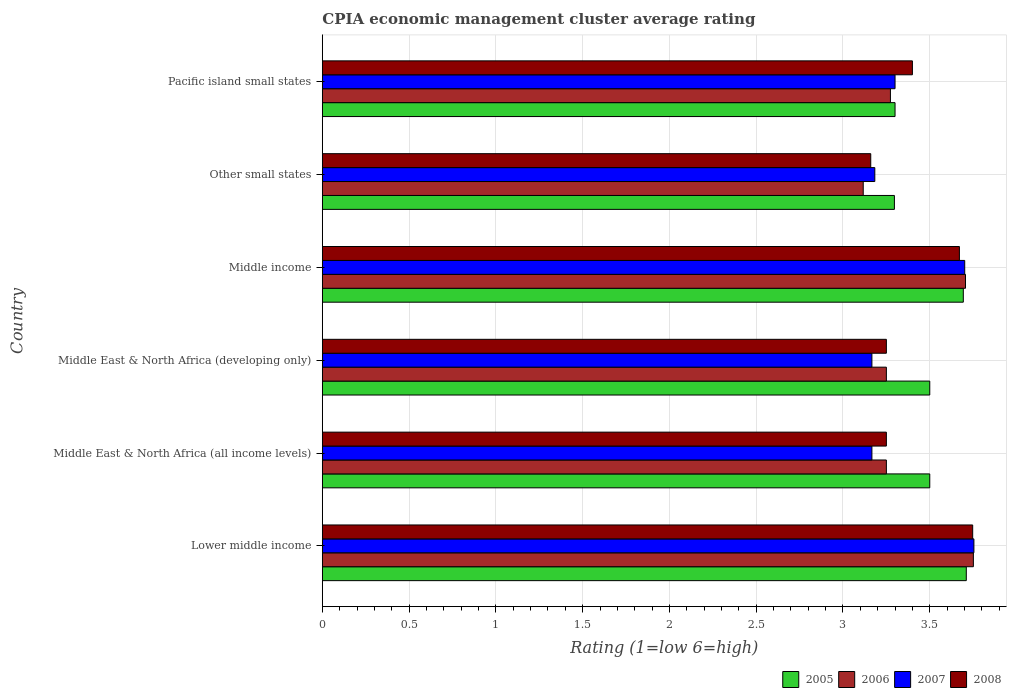Are the number of bars per tick equal to the number of legend labels?
Make the answer very short. Yes. How many bars are there on the 2nd tick from the top?
Your answer should be compact. 4. How many bars are there on the 1st tick from the bottom?
Your answer should be compact. 4. What is the label of the 6th group of bars from the top?
Keep it short and to the point. Lower middle income. In how many cases, is the number of bars for a given country not equal to the number of legend labels?
Make the answer very short. 0. What is the CPIA rating in 2007 in Middle income?
Keep it short and to the point. 3.7. Across all countries, what is the maximum CPIA rating in 2005?
Offer a terse response. 3.71. Across all countries, what is the minimum CPIA rating in 2008?
Provide a succinct answer. 3.16. In which country was the CPIA rating in 2006 maximum?
Offer a terse response. Lower middle income. In which country was the CPIA rating in 2006 minimum?
Ensure brevity in your answer.  Other small states. What is the total CPIA rating in 2006 in the graph?
Provide a short and direct response. 20.35. What is the difference between the CPIA rating in 2007 in Lower middle income and that in Pacific island small states?
Keep it short and to the point. 0.45. What is the difference between the CPIA rating in 2007 in Pacific island small states and the CPIA rating in 2006 in Middle income?
Ensure brevity in your answer.  -0.41. What is the average CPIA rating in 2008 per country?
Offer a terse response. 3.41. What is the difference between the CPIA rating in 2006 and CPIA rating in 2005 in Lower middle income?
Ensure brevity in your answer.  0.04. In how many countries, is the CPIA rating in 2007 greater than 1.2 ?
Provide a succinct answer. 6. What is the ratio of the CPIA rating in 2007 in Middle East & North Africa (all income levels) to that in Other small states?
Your answer should be very brief. 0.99. What is the difference between the highest and the second highest CPIA rating in 2006?
Offer a very short reply. 0.05. What is the difference between the highest and the lowest CPIA rating in 2008?
Offer a terse response. 0.59. In how many countries, is the CPIA rating in 2007 greater than the average CPIA rating in 2007 taken over all countries?
Keep it short and to the point. 2. How many bars are there?
Ensure brevity in your answer.  24. Are all the bars in the graph horizontal?
Keep it short and to the point. Yes. How many countries are there in the graph?
Make the answer very short. 6. Where does the legend appear in the graph?
Keep it short and to the point. Bottom right. How many legend labels are there?
Offer a very short reply. 4. What is the title of the graph?
Provide a short and direct response. CPIA economic management cluster average rating. What is the label or title of the X-axis?
Provide a short and direct response. Rating (1=low 6=high). What is the label or title of the Y-axis?
Offer a very short reply. Country. What is the Rating (1=low 6=high) of 2005 in Lower middle income?
Keep it short and to the point. 3.71. What is the Rating (1=low 6=high) of 2006 in Lower middle income?
Keep it short and to the point. 3.75. What is the Rating (1=low 6=high) of 2007 in Lower middle income?
Your answer should be compact. 3.75. What is the Rating (1=low 6=high) of 2008 in Lower middle income?
Offer a very short reply. 3.75. What is the Rating (1=low 6=high) of 2005 in Middle East & North Africa (all income levels)?
Give a very brief answer. 3.5. What is the Rating (1=low 6=high) of 2006 in Middle East & North Africa (all income levels)?
Offer a terse response. 3.25. What is the Rating (1=low 6=high) in 2007 in Middle East & North Africa (all income levels)?
Make the answer very short. 3.17. What is the Rating (1=low 6=high) in 2008 in Middle East & North Africa (all income levels)?
Offer a very short reply. 3.25. What is the Rating (1=low 6=high) of 2005 in Middle East & North Africa (developing only)?
Give a very brief answer. 3.5. What is the Rating (1=low 6=high) of 2007 in Middle East & North Africa (developing only)?
Your response must be concise. 3.17. What is the Rating (1=low 6=high) of 2008 in Middle East & North Africa (developing only)?
Make the answer very short. 3.25. What is the Rating (1=low 6=high) of 2005 in Middle income?
Your answer should be compact. 3.69. What is the Rating (1=low 6=high) of 2006 in Middle income?
Your answer should be compact. 3.71. What is the Rating (1=low 6=high) in 2007 in Middle income?
Your answer should be compact. 3.7. What is the Rating (1=low 6=high) of 2008 in Middle income?
Provide a succinct answer. 3.67. What is the Rating (1=low 6=high) in 2005 in Other small states?
Ensure brevity in your answer.  3.3. What is the Rating (1=low 6=high) of 2006 in Other small states?
Your answer should be compact. 3.12. What is the Rating (1=low 6=high) of 2007 in Other small states?
Keep it short and to the point. 3.18. What is the Rating (1=low 6=high) of 2008 in Other small states?
Give a very brief answer. 3.16. What is the Rating (1=low 6=high) of 2006 in Pacific island small states?
Offer a terse response. 3.27. What is the Rating (1=low 6=high) of 2007 in Pacific island small states?
Ensure brevity in your answer.  3.3. Across all countries, what is the maximum Rating (1=low 6=high) of 2005?
Keep it short and to the point. 3.71. Across all countries, what is the maximum Rating (1=low 6=high) of 2006?
Offer a very short reply. 3.75. Across all countries, what is the maximum Rating (1=low 6=high) in 2007?
Keep it short and to the point. 3.75. Across all countries, what is the maximum Rating (1=low 6=high) in 2008?
Your answer should be very brief. 3.75. Across all countries, what is the minimum Rating (1=low 6=high) of 2005?
Give a very brief answer. 3.3. Across all countries, what is the minimum Rating (1=low 6=high) of 2006?
Give a very brief answer. 3.12. Across all countries, what is the minimum Rating (1=low 6=high) of 2007?
Provide a short and direct response. 3.17. Across all countries, what is the minimum Rating (1=low 6=high) in 2008?
Make the answer very short. 3.16. What is the total Rating (1=low 6=high) of 2005 in the graph?
Provide a short and direct response. 21. What is the total Rating (1=low 6=high) in 2006 in the graph?
Ensure brevity in your answer.  20.35. What is the total Rating (1=low 6=high) in 2007 in the graph?
Your answer should be compact. 20.27. What is the total Rating (1=low 6=high) in 2008 in the graph?
Your answer should be very brief. 20.48. What is the difference between the Rating (1=low 6=high) in 2005 in Lower middle income and that in Middle East & North Africa (all income levels)?
Offer a terse response. 0.21. What is the difference between the Rating (1=low 6=high) of 2006 in Lower middle income and that in Middle East & North Africa (all income levels)?
Your answer should be very brief. 0.5. What is the difference between the Rating (1=low 6=high) of 2007 in Lower middle income and that in Middle East & North Africa (all income levels)?
Provide a succinct answer. 0.59. What is the difference between the Rating (1=low 6=high) in 2008 in Lower middle income and that in Middle East & North Africa (all income levels)?
Give a very brief answer. 0.5. What is the difference between the Rating (1=low 6=high) in 2005 in Lower middle income and that in Middle East & North Africa (developing only)?
Make the answer very short. 0.21. What is the difference between the Rating (1=low 6=high) of 2006 in Lower middle income and that in Middle East & North Africa (developing only)?
Provide a short and direct response. 0.5. What is the difference between the Rating (1=low 6=high) of 2007 in Lower middle income and that in Middle East & North Africa (developing only)?
Your answer should be very brief. 0.59. What is the difference between the Rating (1=low 6=high) of 2008 in Lower middle income and that in Middle East & North Africa (developing only)?
Keep it short and to the point. 0.5. What is the difference between the Rating (1=low 6=high) of 2005 in Lower middle income and that in Middle income?
Offer a very short reply. 0.02. What is the difference between the Rating (1=low 6=high) in 2006 in Lower middle income and that in Middle income?
Give a very brief answer. 0.05. What is the difference between the Rating (1=low 6=high) of 2007 in Lower middle income and that in Middle income?
Make the answer very short. 0.05. What is the difference between the Rating (1=low 6=high) in 2008 in Lower middle income and that in Middle income?
Your answer should be compact. 0.08. What is the difference between the Rating (1=low 6=high) of 2005 in Lower middle income and that in Other small states?
Your response must be concise. 0.41. What is the difference between the Rating (1=low 6=high) of 2006 in Lower middle income and that in Other small states?
Keep it short and to the point. 0.63. What is the difference between the Rating (1=low 6=high) of 2007 in Lower middle income and that in Other small states?
Provide a short and direct response. 0.57. What is the difference between the Rating (1=low 6=high) of 2008 in Lower middle income and that in Other small states?
Make the answer very short. 0.59. What is the difference between the Rating (1=low 6=high) of 2005 in Lower middle income and that in Pacific island small states?
Offer a very short reply. 0.41. What is the difference between the Rating (1=low 6=high) of 2006 in Lower middle income and that in Pacific island small states?
Your response must be concise. 0.48. What is the difference between the Rating (1=low 6=high) of 2007 in Lower middle income and that in Pacific island small states?
Offer a very short reply. 0.45. What is the difference between the Rating (1=low 6=high) in 2008 in Lower middle income and that in Pacific island small states?
Provide a succinct answer. 0.35. What is the difference between the Rating (1=low 6=high) in 2006 in Middle East & North Africa (all income levels) and that in Middle East & North Africa (developing only)?
Keep it short and to the point. 0. What is the difference between the Rating (1=low 6=high) in 2008 in Middle East & North Africa (all income levels) and that in Middle East & North Africa (developing only)?
Provide a succinct answer. 0. What is the difference between the Rating (1=low 6=high) in 2005 in Middle East & North Africa (all income levels) and that in Middle income?
Ensure brevity in your answer.  -0.19. What is the difference between the Rating (1=low 6=high) of 2006 in Middle East & North Africa (all income levels) and that in Middle income?
Make the answer very short. -0.46. What is the difference between the Rating (1=low 6=high) of 2007 in Middle East & North Africa (all income levels) and that in Middle income?
Provide a short and direct response. -0.53. What is the difference between the Rating (1=low 6=high) of 2008 in Middle East & North Africa (all income levels) and that in Middle income?
Provide a short and direct response. -0.42. What is the difference between the Rating (1=low 6=high) in 2005 in Middle East & North Africa (all income levels) and that in Other small states?
Your response must be concise. 0.2. What is the difference between the Rating (1=low 6=high) of 2006 in Middle East & North Africa (all income levels) and that in Other small states?
Your answer should be compact. 0.13. What is the difference between the Rating (1=low 6=high) in 2007 in Middle East & North Africa (all income levels) and that in Other small states?
Make the answer very short. -0.02. What is the difference between the Rating (1=low 6=high) of 2008 in Middle East & North Africa (all income levels) and that in Other small states?
Make the answer very short. 0.09. What is the difference between the Rating (1=low 6=high) of 2006 in Middle East & North Africa (all income levels) and that in Pacific island small states?
Keep it short and to the point. -0.02. What is the difference between the Rating (1=low 6=high) in 2007 in Middle East & North Africa (all income levels) and that in Pacific island small states?
Make the answer very short. -0.13. What is the difference between the Rating (1=low 6=high) in 2008 in Middle East & North Africa (all income levels) and that in Pacific island small states?
Provide a succinct answer. -0.15. What is the difference between the Rating (1=low 6=high) in 2005 in Middle East & North Africa (developing only) and that in Middle income?
Provide a succinct answer. -0.19. What is the difference between the Rating (1=low 6=high) of 2006 in Middle East & North Africa (developing only) and that in Middle income?
Provide a succinct answer. -0.46. What is the difference between the Rating (1=low 6=high) in 2007 in Middle East & North Africa (developing only) and that in Middle income?
Provide a short and direct response. -0.53. What is the difference between the Rating (1=low 6=high) in 2008 in Middle East & North Africa (developing only) and that in Middle income?
Give a very brief answer. -0.42. What is the difference between the Rating (1=low 6=high) in 2005 in Middle East & North Africa (developing only) and that in Other small states?
Provide a succinct answer. 0.2. What is the difference between the Rating (1=low 6=high) of 2006 in Middle East & North Africa (developing only) and that in Other small states?
Provide a short and direct response. 0.13. What is the difference between the Rating (1=low 6=high) of 2007 in Middle East & North Africa (developing only) and that in Other small states?
Your response must be concise. -0.02. What is the difference between the Rating (1=low 6=high) of 2008 in Middle East & North Africa (developing only) and that in Other small states?
Provide a succinct answer. 0.09. What is the difference between the Rating (1=low 6=high) of 2006 in Middle East & North Africa (developing only) and that in Pacific island small states?
Your response must be concise. -0.02. What is the difference between the Rating (1=low 6=high) in 2007 in Middle East & North Africa (developing only) and that in Pacific island small states?
Offer a terse response. -0.13. What is the difference between the Rating (1=low 6=high) in 2005 in Middle income and that in Other small states?
Keep it short and to the point. 0.4. What is the difference between the Rating (1=low 6=high) of 2006 in Middle income and that in Other small states?
Your answer should be very brief. 0.59. What is the difference between the Rating (1=low 6=high) in 2007 in Middle income and that in Other small states?
Keep it short and to the point. 0.52. What is the difference between the Rating (1=low 6=high) of 2008 in Middle income and that in Other small states?
Offer a very short reply. 0.51. What is the difference between the Rating (1=low 6=high) in 2005 in Middle income and that in Pacific island small states?
Offer a terse response. 0.39. What is the difference between the Rating (1=low 6=high) in 2006 in Middle income and that in Pacific island small states?
Offer a very short reply. 0.43. What is the difference between the Rating (1=low 6=high) in 2007 in Middle income and that in Pacific island small states?
Ensure brevity in your answer.  0.4. What is the difference between the Rating (1=low 6=high) in 2008 in Middle income and that in Pacific island small states?
Your answer should be very brief. 0.27. What is the difference between the Rating (1=low 6=high) in 2005 in Other small states and that in Pacific island small states?
Your answer should be compact. -0. What is the difference between the Rating (1=low 6=high) of 2006 in Other small states and that in Pacific island small states?
Keep it short and to the point. -0.16. What is the difference between the Rating (1=low 6=high) of 2007 in Other small states and that in Pacific island small states?
Ensure brevity in your answer.  -0.12. What is the difference between the Rating (1=low 6=high) of 2008 in Other small states and that in Pacific island small states?
Offer a very short reply. -0.24. What is the difference between the Rating (1=low 6=high) of 2005 in Lower middle income and the Rating (1=low 6=high) of 2006 in Middle East & North Africa (all income levels)?
Give a very brief answer. 0.46. What is the difference between the Rating (1=low 6=high) in 2005 in Lower middle income and the Rating (1=low 6=high) in 2007 in Middle East & North Africa (all income levels)?
Your response must be concise. 0.54. What is the difference between the Rating (1=low 6=high) in 2005 in Lower middle income and the Rating (1=low 6=high) in 2008 in Middle East & North Africa (all income levels)?
Make the answer very short. 0.46. What is the difference between the Rating (1=low 6=high) in 2006 in Lower middle income and the Rating (1=low 6=high) in 2007 in Middle East & North Africa (all income levels)?
Offer a very short reply. 0.58. What is the difference between the Rating (1=low 6=high) of 2006 in Lower middle income and the Rating (1=low 6=high) of 2008 in Middle East & North Africa (all income levels)?
Your response must be concise. 0.5. What is the difference between the Rating (1=low 6=high) of 2007 in Lower middle income and the Rating (1=low 6=high) of 2008 in Middle East & North Africa (all income levels)?
Your answer should be very brief. 0.5. What is the difference between the Rating (1=low 6=high) in 2005 in Lower middle income and the Rating (1=low 6=high) in 2006 in Middle East & North Africa (developing only)?
Offer a terse response. 0.46. What is the difference between the Rating (1=low 6=high) in 2005 in Lower middle income and the Rating (1=low 6=high) in 2007 in Middle East & North Africa (developing only)?
Your answer should be compact. 0.54. What is the difference between the Rating (1=low 6=high) of 2005 in Lower middle income and the Rating (1=low 6=high) of 2008 in Middle East & North Africa (developing only)?
Give a very brief answer. 0.46. What is the difference between the Rating (1=low 6=high) in 2006 in Lower middle income and the Rating (1=low 6=high) in 2007 in Middle East & North Africa (developing only)?
Offer a terse response. 0.58. What is the difference between the Rating (1=low 6=high) in 2006 in Lower middle income and the Rating (1=low 6=high) in 2008 in Middle East & North Africa (developing only)?
Offer a very short reply. 0.5. What is the difference between the Rating (1=low 6=high) of 2007 in Lower middle income and the Rating (1=low 6=high) of 2008 in Middle East & North Africa (developing only)?
Keep it short and to the point. 0.5. What is the difference between the Rating (1=low 6=high) of 2005 in Lower middle income and the Rating (1=low 6=high) of 2006 in Middle income?
Make the answer very short. 0. What is the difference between the Rating (1=low 6=high) of 2005 in Lower middle income and the Rating (1=low 6=high) of 2007 in Middle income?
Offer a terse response. 0.01. What is the difference between the Rating (1=low 6=high) of 2005 in Lower middle income and the Rating (1=low 6=high) of 2008 in Middle income?
Keep it short and to the point. 0.04. What is the difference between the Rating (1=low 6=high) in 2006 in Lower middle income and the Rating (1=low 6=high) in 2007 in Middle income?
Keep it short and to the point. 0.05. What is the difference between the Rating (1=low 6=high) in 2006 in Lower middle income and the Rating (1=low 6=high) in 2008 in Middle income?
Your answer should be very brief. 0.08. What is the difference between the Rating (1=low 6=high) in 2007 in Lower middle income and the Rating (1=low 6=high) in 2008 in Middle income?
Offer a terse response. 0.08. What is the difference between the Rating (1=low 6=high) in 2005 in Lower middle income and the Rating (1=low 6=high) in 2006 in Other small states?
Provide a short and direct response. 0.59. What is the difference between the Rating (1=low 6=high) of 2005 in Lower middle income and the Rating (1=low 6=high) of 2007 in Other small states?
Your answer should be compact. 0.53. What is the difference between the Rating (1=low 6=high) of 2005 in Lower middle income and the Rating (1=low 6=high) of 2008 in Other small states?
Make the answer very short. 0.55. What is the difference between the Rating (1=low 6=high) of 2006 in Lower middle income and the Rating (1=low 6=high) of 2007 in Other small states?
Your answer should be compact. 0.57. What is the difference between the Rating (1=low 6=high) in 2006 in Lower middle income and the Rating (1=low 6=high) in 2008 in Other small states?
Your answer should be very brief. 0.59. What is the difference between the Rating (1=low 6=high) of 2007 in Lower middle income and the Rating (1=low 6=high) of 2008 in Other small states?
Your answer should be compact. 0.59. What is the difference between the Rating (1=low 6=high) of 2005 in Lower middle income and the Rating (1=low 6=high) of 2006 in Pacific island small states?
Your answer should be very brief. 0.44. What is the difference between the Rating (1=low 6=high) of 2005 in Lower middle income and the Rating (1=low 6=high) of 2007 in Pacific island small states?
Provide a short and direct response. 0.41. What is the difference between the Rating (1=low 6=high) in 2005 in Lower middle income and the Rating (1=low 6=high) in 2008 in Pacific island small states?
Give a very brief answer. 0.31. What is the difference between the Rating (1=low 6=high) in 2006 in Lower middle income and the Rating (1=low 6=high) in 2007 in Pacific island small states?
Keep it short and to the point. 0.45. What is the difference between the Rating (1=low 6=high) of 2006 in Lower middle income and the Rating (1=low 6=high) of 2008 in Pacific island small states?
Your answer should be very brief. 0.35. What is the difference between the Rating (1=low 6=high) of 2007 in Lower middle income and the Rating (1=low 6=high) of 2008 in Pacific island small states?
Offer a very short reply. 0.35. What is the difference between the Rating (1=low 6=high) in 2005 in Middle East & North Africa (all income levels) and the Rating (1=low 6=high) in 2006 in Middle East & North Africa (developing only)?
Offer a terse response. 0.25. What is the difference between the Rating (1=low 6=high) in 2005 in Middle East & North Africa (all income levels) and the Rating (1=low 6=high) in 2007 in Middle East & North Africa (developing only)?
Provide a succinct answer. 0.33. What is the difference between the Rating (1=low 6=high) in 2005 in Middle East & North Africa (all income levels) and the Rating (1=low 6=high) in 2008 in Middle East & North Africa (developing only)?
Make the answer very short. 0.25. What is the difference between the Rating (1=low 6=high) in 2006 in Middle East & North Africa (all income levels) and the Rating (1=low 6=high) in 2007 in Middle East & North Africa (developing only)?
Your answer should be very brief. 0.08. What is the difference between the Rating (1=low 6=high) in 2007 in Middle East & North Africa (all income levels) and the Rating (1=low 6=high) in 2008 in Middle East & North Africa (developing only)?
Keep it short and to the point. -0.08. What is the difference between the Rating (1=low 6=high) of 2005 in Middle East & North Africa (all income levels) and the Rating (1=low 6=high) of 2006 in Middle income?
Keep it short and to the point. -0.21. What is the difference between the Rating (1=low 6=high) in 2005 in Middle East & North Africa (all income levels) and the Rating (1=low 6=high) in 2007 in Middle income?
Offer a very short reply. -0.2. What is the difference between the Rating (1=low 6=high) in 2005 in Middle East & North Africa (all income levels) and the Rating (1=low 6=high) in 2008 in Middle income?
Offer a terse response. -0.17. What is the difference between the Rating (1=low 6=high) in 2006 in Middle East & North Africa (all income levels) and the Rating (1=low 6=high) in 2007 in Middle income?
Make the answer very short. -0.45. What is the difference between the Rating (1=low 6=high) in 2006 in Middle East & North Africa (all income levels) and the Rating (1=low 6=high) in 2008 in Middle income?
Your answer should be compact. -0.42. What is the difference between the Rating (1=low 6=high) in 2007 in Middle East & North Africa (all income levels) and the Rating (1=low 6=high) in 2008 in Middle income?
Keep it short and to the point. -0.5. What is the difference between the Rating (1=low 6=high) in 2005 in Middle East & North Africa (all income levels) and the Rating (1=low 6=high) in 2006 in Other small states?
Offer a very short reply. 0.38. What is the difference between the Rating (1=low 6=high) of 2005 in Middle East & North Africa (all income levels) and the Rating (1=low 6=high) of 2007 in Other small states?
Offer a very short reply. 0.32. What is the difference between the Rating (1=low 6=high) in 2005 in Middle East & North Africa (all income levels) and the Rating (1=low 6=high) in 2008 in Other small states?
Offer a terse response. 0.34. What is the difference between the Rating (1=low 6=high) in 2006 in Middle East & North Africa (all income levels) and the Rating (1=low 6=high) in 2007 in Other small states?
Provide a succinct answer. 0.07. What is the difference between the Rating (1=low 6=high) of 2006 in Middle East & North Africa (all income levels) and the Rating (1=low 6=high) of 2008 in Other small states?
Provide a succinct answer. 0.09. What is the difference between the Rating (1=low 6=high) of 2007 in Middle East & North Africa (all income levels) and the Rating (1=low 6=high) of 2008 in Other small states?
Make the answer very short. 0.01. What is the difference between the Rating (1=low 6=high) in 2005 in Middle East & North Africa (all income levels) and the Rating (1=low 6=high) in 2006 in Pacific island small states?
Give a very brief answer. 0.23. What is the difference between the Rating (1=low 6=high) in 2005 in Middle East & North Africa (all income levels) and the Rating (1=low 6=high) in 2007 in Pacific island small states?
Your answer should be very brief. 0.2. What is the difference between the Rating (1=low 6=high) of 2006 in Middle East & North Africa (all income levels) and the Rating (1=low 6=high) of 2007 in Pacific island small states?
Your response must be concise. -0.05. What is the difference between the Rating (1=low 6=high) of 2007 in Middle East & North Africa (all income levels) and the Rating (1=low 6=high) of 2008 in Pacific island small states?
Your answer should be compact. -0.23. What is the difference between the Rating (1=low 6=high) of 2005 in Middle East & North Africa (developing only) and the Rating (1=low 6=high) of 2006 in Middle income?
Make the answer very short. -0.21. What is the difference between the Rating (1=low 6=high) of 2005 in Middle East & North Africa (developing only) and the Rating (1=low 6=high) of 2007 in Middle income?
Offer a terse response. -0.2. What is the difference between the Rating (1=low 6=high) in 2005 in Middle East & North Africa (developing only) and the Rating (1=low 6=high) in 2008 in Middle income?
Your response must be concise. -0.17. What is the difference between the Rating (1=low 6=high) of 2006 in Middle East & North Africa (developing only) and the Rating (1=low 6=high) of 2007 in Middle income?
Keep it short and to the point. -0.45. What is the difference between the Rating (1=low 6=high) in 2006 in Middle East & North Africa (developing only) and the Rating (1=low 6=high) in 2008 in Middle income?
Keep it short and to the point. -0.42. What is the difference between the Rating (1=low 6=high) of 2007 in Middle East & North Africa (developing only) and the Rating (1=low 6=high) of 2008 in Middle income?
Your answer should be compact. -0.5. What is the difference between the Rating (1=low 6=high) in 2005 in Middle East & North Africa (developing only) and the Rating (1=low 6=high) in 2006 in Other small states?
Provide a succinct answer. 0.38. What is the difference between the Rating (1=low 6=high) of 2005 in Middle East & North Africa (developing only) and the Rating (1=low 6=high) of 2007 in Other small states?
Keep it short and to the point. 0.32. What is the difference between the Rating (1=low 6=high) in 2005 in Middle East & North Africa (developing only) and the Rating (1=low 6=high) in 2008 in Other small states?
Make the answer very short. 0.34. What is the difference between the Rating (1=low 6=high) of 2006 in Middle East & North Africa (developing only) and the Rating (1=low 6=high) of 2007 in Other small states?
Keep it short and to the point. 0.07. What is the difference between the Rating (1=low 6=high) in 2006 in Middle East & North Africa (developing only) and the Rating (1=low 6=high) in 2008 in Other small states?
Offer a terse response. 0.09. What is the difference between the Rating (1=low 6=high) in 2007 in Middle East & North Africa (developing only) and the Rating (1=low 6=high) in 2008 in Other small states?
Give a very brief answer. 0.01. What is the difference between the Rating (1=low 6=high) in 2005 in Middle East & North Africa (developing only) and the Rating (1=low 6=high) in 2006 in Pacific island small states?
Offer a terse response. 0.23. What is the difference between the Rating (1=low 6=high) in 2006 in Middle East & North Africa (developing only) and the Rating (1=low 6=high) in 2008 in Pacific island small states?
Provide a short and direct response. -0.15. What is the difference between the Rating (1=low 6=high) in 2007 in Middle East & North Africa (developing only) and the Rating (1=low 6=high) in 2008 in Pacific island small states?
Your response must be concise. -0.23. What is the difference between the Rating (1=low 6=high) in 2005 in Middle income and the Rating (1=low 6=high) in 2006 in Other small states?
Make the answer very short. 0.58. What is the difference between the Rating (1=low 6=high) in 2005 in Middle income and the Rating (1=low 6=high) in 2007 in Other small states?
Provide a succinct answer. 0.51. What is the difference between the Rating (1=low 6=high) in 2005 in Middle income and the Rating (1=low 6=high) in 2008 in Other small states?
Provide a short and direct response. 0.53. What is the difference between the Rating (1=low 6=high) in 2006 in Middle income and the Rating (1=low 6=high) in 2007 in Other small states?
Ensure brevity in your answer.  0.52. What is the difference between the Rating (1=low 6=high) of 2006 in Middle income and the Rating (1=low 6=high) of 2008 in Other small states?
Give a very brief answer. 0.55. What is the difference between the Rating (1=low 6=high) in 2007 in Middle income and the Rating (1=low 6=high) in 2008 in Other small states?
Your answer should be compact. 0.54. What is the difference between the Rating (1=low 6=high) of 2005 in Middle income and the Rating (1=low 6=high) of 2006 in Pacific island small states?
Provide a short and direct response. 0.42. What is the difference between the Rating (1=low 6=high) of 2005 in Middle income and the Rating (1=low 6=high) of 2007 in Pacific island small states?
Your answer should be very brief. 0.39. What is the difference between the Rating (1=low 6=high) in 2005 in Middle income and the Rating (1=low 6=high) in 2008 in Pacific island small states?
Provide a succinct answer. 0.29. What is the difference between the Rating (1=low 6=high) of 2006 in Middle income and the Rating (1=low 6=high) of 2007 in Pacific island small states?
Make the answer very short. 0.41. What is the difference between the Rating (1=low 6=high) of 2006 in Middle income and the Rating (1=low 6=high) of 2008 in Pacific island small states?
Provide a short and direct response. 0.31. What is the difference between the Rating (1=low 6=high) in 2007 in Middle income and the Rating (1=low 6=high) in 2008 in Pacific island small states?
Ensure brevity in your answer.  0.3. What is the difference between the Rating (1=low 6=high) of 2005 in Other small states and the Rating (1=low 6=high) of 2006 in Pacific island small states?
Provide a succinct answer. 0.02. What is the difference between the Rating (1=low 6=high) in 2005 in Other small states and the Rating (1=low 6=high) in 2007 in Pacific island small states?
Provide a short and direct response. -0. What is the difference between the Rating (1=low 6=high) of 2005 in Other small states and the Rating (1=low 6=high) of 2008 in Pacific island small states?
Your answer should be compact. -0.1. What is the difference between the Rating (1=low 6=high) of 2006 in Other small states and the Rating (1=low 6=high) of 2007 in Pacific island small states?
Your answer should be very brief. -0.18. What is the difference between the Rating (1=low 6=high) of 2006 in Other small states and the Rating (1=low 6=high) of 2008 in Pacific island small states?
Make the answer very short. -0.28. What is the difference between the Rating (1=low 6=high) in 2007 in Other small states and the Rating (1=low 6=high) in 2008 in Pacific island small states?
Give a very brief answer. -0.22. What is the average Rating (1=low 6=high) in 2006 per country?
Provide a succinct answer. 3.39. What is the average Rating (1=low 6=high) of 2007 per country?
Your response must be concise. 3.38. What is the average Rating (1=low 6=high) of 2008 per country?
Provide a short and direct response. 3.41. What is the difference between the Rating (1=low 6=high) of 2005 and Rating (1=low 6=high) of 2006 in Lower middle income?
Your response must be concise. -0.04. What is the difference between the Rating (1=low 6=high) in 2005 and Rating (1=low 6=high) in 2007 in Lower middle income?
Keep it short and to the point. -0.04. What is the difference between the Rating (1=low 6=high) of 2005 and Rating (1=low 6=high) of 2008 in Lower middle income?
Your answer should be very brief. -0.04. What is the difference between the Rating (1=low 6=high) of 2006 and Rating (1=low 6=high) of 2007 in Lower middle income?
Keep it short and to the point. -0. What is the difference between the Rating (1=low 6=high) in 2006 and Rating (1=low 6=high) in 2008 in Lower middle income?
Your answer should be compact. 0. What is the difference between the Rating (1=low 6=high) in 2007 and Rating (1=low 6=high) in 2008 in Lower middle income?
Provide a succinct answer. 0.01. What is the difference between the Rating (1=low 6=high) of 2005 and Rating (1=low 6=high) of 2006 in Middle East & North Africa (all income levels)?
Provide a short and direct response. 0.25. What is the difference between the Rating (1=low 6=high) in 2005 and Rating (1=low 6=high) in 2007 in Middle East & North Africa (all income levels)?
Keep it short and to the point. 0.33. What is the difference between the Rating (1=low 6=high) in 2005 and Rating (1=low 6=high) in 2008 in Middle East & North Africa (all income levels)?
Ensure brevity in your answer.  0.25. What is the difference between the Rating (1=low 6=high) in 2006 and Rating (1=low 6=high) in 2007 in Middle East & North Africa (all income levels)?
Provide a short and direct response. 0.08. What is the difference between the Rating (1=low 6=high) of 2006 and Rating (1=low 6=high) of 2008 in Middle East & North Africa (all income levels)?
Your answer should be compact. 0. What is the difference between the Rating (1=low 6=high) of 2007 and Rating (1=low 6=high) of 2008 in Middle East & North Africa (all income levels)?
Your answer should be very brief. -0.08. What is the difference between the Rating (1=low 6=high) of 2005 and Rating (1=low 6=high) of 2006 in Middle East & North Africa (developing only)?
Make the answer very short. 0.25. What is the difference between the Rating (1=low 6=high) of 2006 and Rating (1=low 6=high) of 2007 in Middle East & North Africa (developing only)?
Keep it short and to the point. 0.08. What is the difference between the Rating (1=low 6=high) in 2006 and Rating (1=low 6=high) in 2008 in Middle East & North Africa (developing only)?
Your answer should be very brief. 0. What is the difference between the Rating (1=low 6=high) in 2007 and Rating (1=low 6=high) in 2008 in Middle East & North Africa (developing only)?
Your response must be concise. -0.08. What is the difference between the Rating (1=low 6=high) in 2005 and Rating (1=low 6=high) in 2006 in Middle income?
Provide a short and direct response. -0.01. What is the difference between the Rating (1=low 6=high) in 2005 and Rating (1=low 6=high) in 2007 in Middle income?
Offer a terse response. -0.01. What is the difference between the Rating (1=low 6=high) of 2005 and Rating (1=low 6=high) of 2008 in Middle income?
Offer a very short reply. 0.02. What is the difference between the Rating (1=low 6=high) of 2006 and Rating (1=low 6=high) of 2007 in Middle income?
Provide a short and direct response. 0. What is the difference between the Rating (1=low 6=high) in 2006 and Rating (1=low 6=high) in 2008 in Middle income?
Keep it short and to the point. 0.04. What is the difference between the Rating (1=low 6=high) of 2007 and Rating (1=low 6=high) of 2008 in Middle income?
Your answer should be compact. 0.03. What is the difference between the Rating (1=low 6=high) in 2005 and Rating (1=low 6=high) in 2006 in Other small states?
Keep it short and to the point. 0.18. What is the difference between the Rating (1=low 6=high) in 2005 and Rating (1=low 6=high) in 2007 in Other small states?
Provide a short and direct response. 0.11. What is the difference between the Rating (1=low 6=high) in 2005 and Rating (1=low 6=high) in 2008 in Other small states?
Your response must be concise. 0.14. What is the difference between the Rating (1=low 6=high) of 2006 and Rating (1=low 6=high) of 2007 in Other small states?
Provide a short and direct response. -0.07. What is the difference between the Rating (1=low 6=high) of 2006 and Rating (1=low 6=high) of 2008 in Other small states?
Keep it short and to the point. -0.04. What is the difference between the Rating (1=low 6=high) in 2007 and Rating (1=low 6=high) in 2008 in Other small states?
Your response must be concise. 0.02. What is the difference between the Rating (1=low 6=high) in 2005 and Rating (1=low 6=high) in 2006 in Pacific island small states?
Provide a succinct answer. 0.03. What is the difference between the Rating (1=low 6=high) of 2005 and Rating (1=low 6=high) of 2007 in Pacific island small states?
Your answer should be very brief. 0. What is the difference between the Rating (1=low 6=high) in 2006 and Rating (1=low 6=high) in 2007 in Pacific island small states?
Offer a very short reply. -0.03. What is the difference between the Rating (1=low 6=high) in 2006 and Rating (1=low 6=high) in 2008 in Pacific island small states?
Offer a terse response. -0.13. What is the ratio of the Rating (1=low 6=high) in 2005 in Lower middle income to that in Middle East & North Africa (all income levels)?
Your response must be concise. 1.06. What is the ratio of the Rating (1=low 6=high) of 2006 in Lower middle income to that in Middle East & North Africa (all income levels)?
Offer a terse response. 1.15. What is the ratio of the Rating (1=low 6=high) of 2007 in Lower middle income to that in Middle East & North Africa (all income levels)?
Keep it short and to the point. 1.19. What is the ratio of the Rating (1=low 6=high) of 2008 in Lower middle income to that in Middle East & North Africa (all income levels)?
Make the answer very short. 1.15. What is the ratio of the Rating (1=low 6=high) of 2005 in Lower middle income to that in Middle East & North Africa (developing only)?
Your answer should be compact. 1.06. What is the ratio of the Rating (1=low 6=high) of 2006 in Lower middle income to that in Middle East & North Africa (developing only)?
Keep it short and to the point. 1.15. What is the ratio of the Rating (1=low 6=high) in 2007 in Lower middle income to that in Middle East & North Africa (developing only)?
Offer a terse response. 1.19. What is the ratio of the Rating (1=low 6=high) in 2008 in Lower middle income to that in Middle East & North Africa (developing only)?
Make the answer very short. 1.15. What is the ratio of the Rating (1=low 6=high) in 2005 in Lower middle income to that in Middle income?
Provide a succinct answer. 1. What is the ratio of the Rating (1=low 6=high) of 2006 in Lower middle income to that in Middle income?
Provide a short and direct response. 1.01. What is the ratio of the Rating (1=low 6=high) of 2007 in Lower middle income to that in Middle income?
Make the answer very short. 1.01. What is the ratio of the Rating (1=low 6=high) of 2008 in Lower middle income to that in Middle income?
Offer a very short reply. 1.02. What is the ratio of the Rating (1=low 6=high) of 2005 in Lower middle income to that in Other small states?
Your answer should be compact. 1.13. What is the ratio of the Rating (1=low 6=high) of 2006 in Lower middle income to that in Other small states?
Keep it short and to the point. 1.2. What is the ratio of the Rating (1=low 6=high) in 2007 in Lower middle income to that in Other small states?
Make the answer very short. 1.18. What is the ratio of the Rating (1=low 6=high) of 2008 in Lower middle income to that in Other small states?
Your answer should be compact. 1.19. What is the ratio of the Rating (1=low 6=high) in 2005 in Lower middle income to that in Pacific island small states?
Make the answer very short. 1.12. What is the ratio of the Rating (1=low 6=high) of 2006 in Lower middle income to that in Pacific island small states?
Offer a very short reply. 1.15. What is the ratio of the Rating (1=low 6=high) of 2007 in Lower middle income to that in Pacific island small states?
Your response must be concise. 1.14. What is the ratio of the Rating (1=low 6=high) of 2008 in Lower middle income to that in Pacific island small states?
Give a very brief answer. 1.1. What is the ratio of the Rating (1=low 6=high) of 2006 in Middle East & North Africa (all income levels) to that in Middle East & North Africa (developing only)?
Offer a terse response. 1. What is the ratio of the Rating (1=low 6=high) in 2005 in Middle East & North Africa (all income levels) to that in Middle income?
Provide a short and direct response. 0.95. What is the ratio of the Rating (1=low 6=high) in 2006 in Middle East & North Africa (all income levels) to that in Middle income?
Offer a very short reply. 0.88. What is the ratio of the Rating (1=low 6=high) of 2007 in Middle East & North Africa (all income levels) to that in Middle income?
Your answer should be compact. 0.86. What is the ratio of the Rating (1=low 6=high) of 2008 in Middle East & North Africa (all income levels) to that in Middle income?
Your response must be concise. 0.89. What is the ratio of the Rating (1=low 6=high) in 2005 in Middle East & North Africa (all income levels) to that in Other small states?
Make the answer very short. 1.06. What is the ratio of the Rating (1=low 6=high) of 2006 in Middle East & North Africa (all income levels) to that in Other small states?
Ensure brevity in your answer.  1.04. What is the ratio of the Rating (1=low 6=high) of 2007 in Middle East & North Africa (all income levels) to that in Other small states?
Keep it short and to the point. 0.99. What is the ratio of the Rating (1=low 6=high) of 2008 in Middle East & North Africa (all income levels) to that in Other small states?
Your response must be concise. 1.03. What is the ratio of the Rating (1=low 6=high) of 2005 in Middle East & North Africa (all income levels) to that in Pacific island small states?
Offer a very short reply. 1.06. What is the ratio of the Rating (1=low 6=high) of 2007 in Middle East & North Africa (all income levels) to that in Pacific island small states?
Ensure brevity in your answer.  0.96. What is the ratio of the Rating (1=low 6=high) in 2008 in Middle East & North Africa (all income levels) to that in Pacific island small states?
Your answer should be very brief. 0.96. What is the ratio of the Rating (1=low 6=high) in 2005 in Middle East & North Africa (developing only) to that in Middle income?
Your answer should be very brief. 0.95. What is the ratio of the Rating (1=low 6=high) in 2006 in Middle East & North Africa (developing only) to that in Middle income?
Provide a short and direct response. 0.88. What is the ratio of the Rating (1=low 6=high) of 2007 in Middle East & North Africa (developing only) to that in Middle income?
Ensure brevity in your answer.  0.86. What is the ratio of the Rating (1=low 6=high) in 2008 in Middle East & North Africa (developing only) to that in Middle income?
Ensure brevity in your answer.  0.89. What is the ratio of the Rating (1=low 6=high) of 2005 in Middle East & North Africa (developing only) to that in Other small states?
Offer a terse response. 1.06. What is the ratio of the Rating (1=low 6=high) in 2006 in Middle East & North Africa (developing only) to that in Other small states?
Your answer should be compact. 1.04. What is the ratio of the Rating (1=low 6=high) of 2008 in Middle East & North Africa (developing only) to that in Other small states?
Your answer should be very brief. 1.03. What is the ratio of the Rating (1=low 6=high) in 2005 in Middle East & North Africa (developing only) to that in Pacific island small states?
Your answer should be very brief. 1.06. What is the ratio of the Rating (1=low 6=high) of 2006 in Middle East & North Africa (developing only) to that in Pacific island small states?
Ensure brevity in your answer.  0.99. What is the ratio of the Rating (1=low 6=high) of 2007 in Middle East & North Africa (developing only) to that in Pacific island small states?
Provide a succinct answer. 0.96. What is the ratio of the Rating (1=low 6=high) in 2008 in Middle East & North Africa (developing only) to that in Pacific island small states?
Keep it short and to the point. 0.96. What is the ratio of the Rating (1=low 6=high) in 2005 in Middle income to that in Other small states?
Offer a very short reply. 1.12. What is the ratio of the Rating (1=low 6=high) of 2006 in Middle income to that in Other small states?
Give a very brief answer. 1.19. What is the ratio of the Rating (1=low 6=high) of 2007 in Middle income to that in Other small states?
Offer a very short reply. 1.16. What is the ratio of the Rating (1=low 6=high) in 2008 in Middle income to that in Other small states?
Make the answer very short. 1.16. What is the ratio of the Rating (1=low 6=high) in 2005 in Middle income to that in Pacific island small states?
Give a very brief answer. 1.12. What is the ratio of the Rating (1=low 6=high) in 2006 in Middle income to that in Pacific island small states?
Keep it short and to the point. 1.13. What is the ratio of the Rating (1=low 6=high) in 2007 in Middle income to that in Pacific island small states?
Your response must be concise. 1.12. What is the ratio of the Rating (1=low 6=high) of 2008 in Middle income to that in Pacific island small states?
Provide a short and direct response. 1.08. What is the ratio of the Rating (1=low 6=high) of 2005 in Other small states to that in Pacific island small states?
Offer a very short reply. 1. What is the ratio of the Rating (1=low 6=high) in 2006 in Other small states to that in Pacific island small states?
Ensure brevity in your answer.  0.95. What is the ratio of the Rating (1=low 6=high) in 2007 in Other small states to that in Pacific island small states?
Ensure brevity in your answer.  0.96. What is the ratio of the Rating (1=low 6=high) of 2008 in Other small states to that in Pacific island small states?
Ensure brevity in your answer.  0.93. What is the difference between the highest and the second highest Rating (1=low 6=high) in 2005?
Your response must be concise. 0.02. What is the difference between the highest and the second highest Rating (1=low 6=high) in 2006?
Offer a terse response. 0.05. What is the difference between the highest and the second highest Rating (1=low 6=high) in 2007?
Provide a short and direct response. 0.05. What is the difference between the highest and the second highest Rating (1=low 6=high) in 2008?
Keep it short and to the point. 0.08. What is the difference between the highest and the lowest Rating (1=low 6=high) of 2005?
Give a very brief answer. 0.41. What is the difference between the highest and the lowest Rating (1=low 6=high) of 2006?
Your answer should be very brief. 0.63. What is the difference between the highest and the lowest Rating (1=low 6=high) of 2007?
Provide a short and direct response. 0.59. What is the difference between the highest and the lowest Rating (1=low 6=high) of 2008?
Your answer should be very brief. 0.59. 